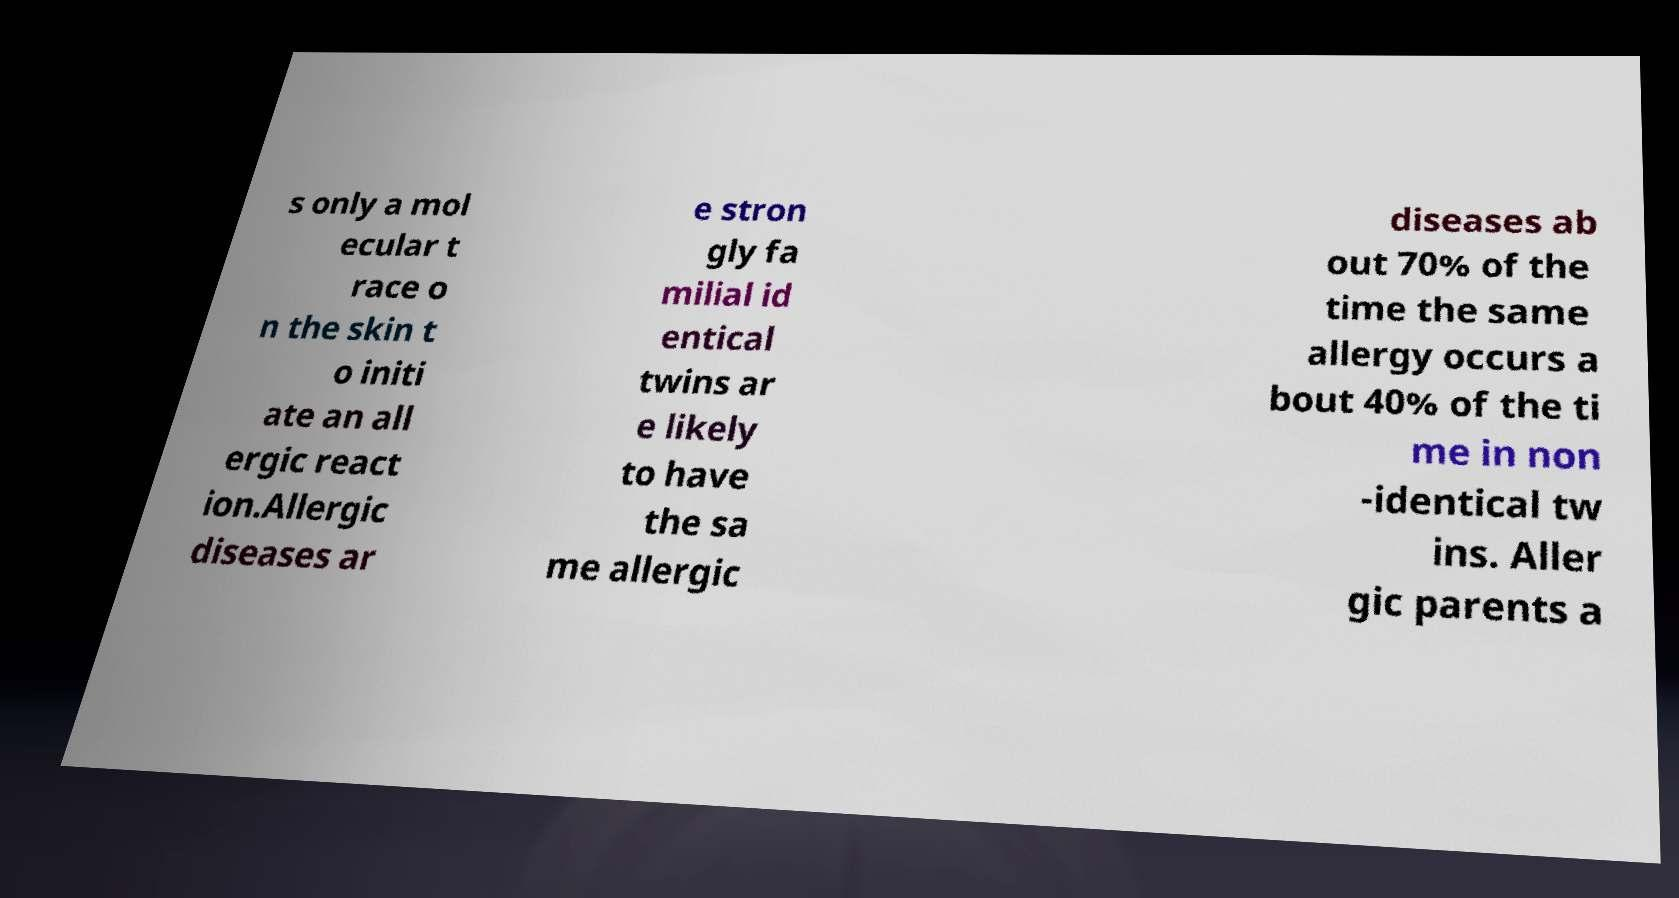Please read and relay the text visible in this image. What does it say? s only a mol ecular t race o n the skin t o initi ate an all ergic react ion.Allergic diseases ar e stron gly fa milial id entical twins ar e likely to have the sa me allergic diseases ab out 70% of the time the same allergy occurs a bout 40% of the ti me in non -identical tw ins. Aller gic parents a 